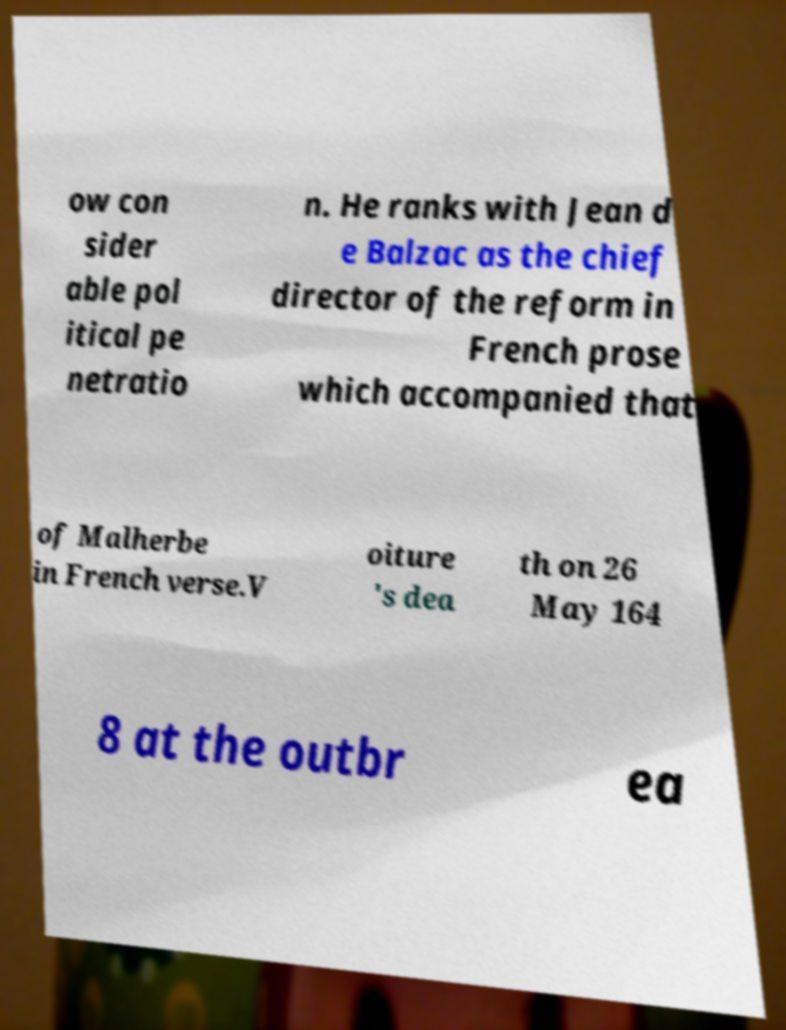Please read and relay the text visible in this image. What does it say? ow con sider able pol itical pe netratio n. He ranks with Jean d e Balzac as the chief director of the reform in French prose which accompanied that of Malherbe in French verse.V oiture 's dea th on 26 May 164 8 at the outbr ea 